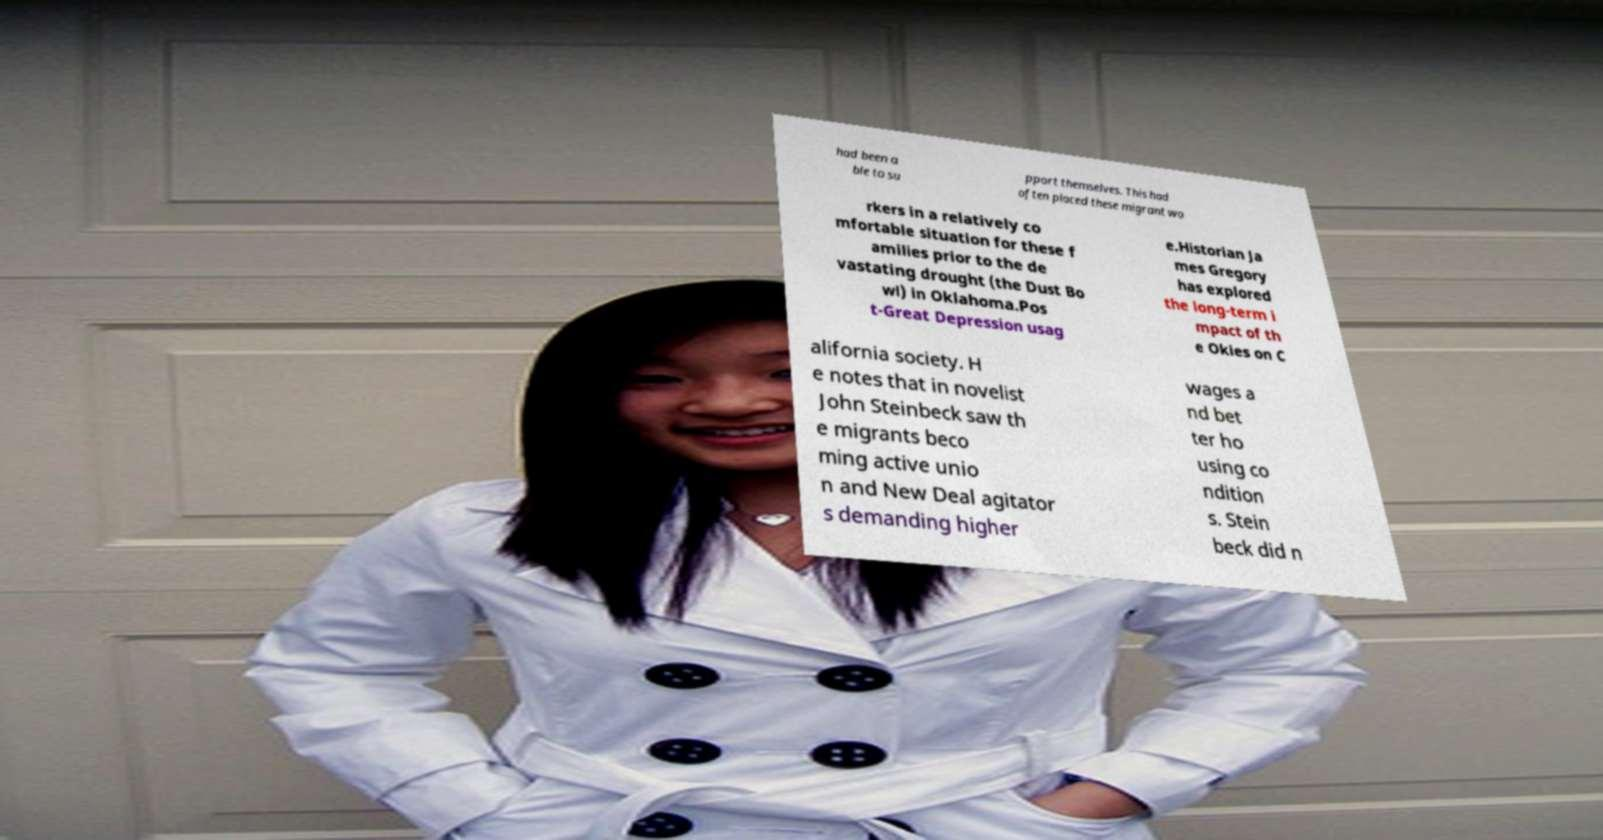I need the written content from this picture converted into text. Can you do that? had been a ble to su pport themselves. This had often placed these migrant wo rkers in a relatively co mfortable situation for these f amilies prior to the de vastating drought (the Dust Bo wl) in Oklahoma.Pos t-Great Depression usag e.Historian Ja mes Gregory has explored the long-term i mpact of th e Okies on C alifornia society. H e notes that in novelist John Steinbeck saw th e migrants beco ming active unio n and New Deal agitator s demanding higher wages a nd bet ter ho using co ndition s. Stein beck did n 